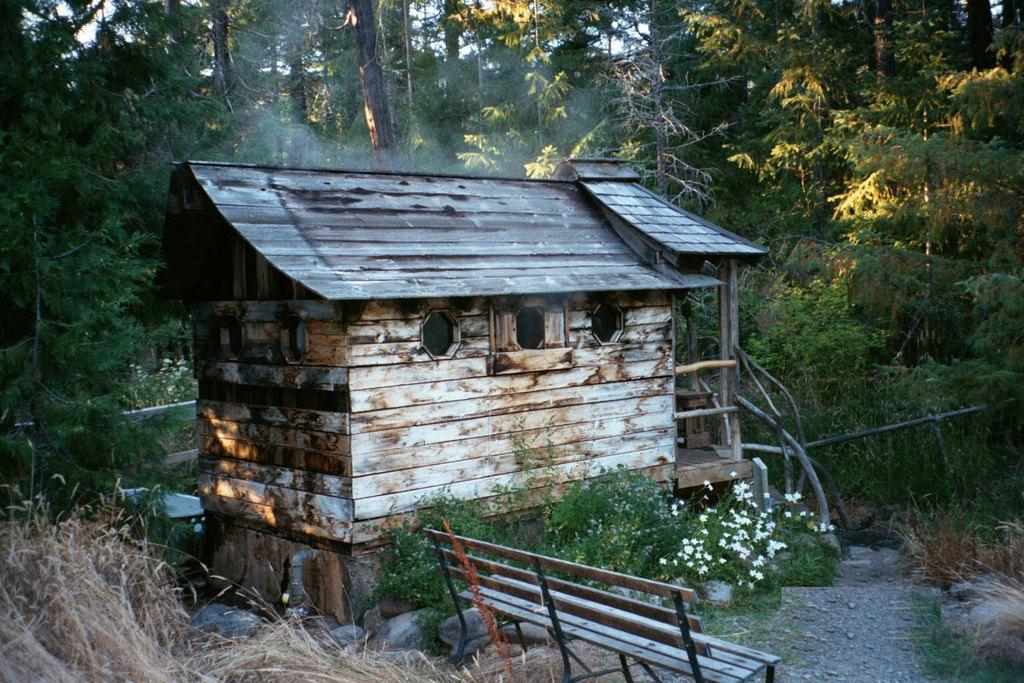What type of structure is present in the image? There is a house in the image. What type of outdoor furniture can be seen in the image? There is a bench in the image. What type of plants are visible in the image? There are flowers and trees in the image. What can be seen in the background of the image? The sky is visible in the background of the image. How many friends are sitting on the bench with the dinosaurs in the image? There are no friends or dinosaurs present in the image. What type of increase can be observed in the number of flowers in the image? There is no indication of an increase in the number of flowers in the image; the number of flowers remains constant. 